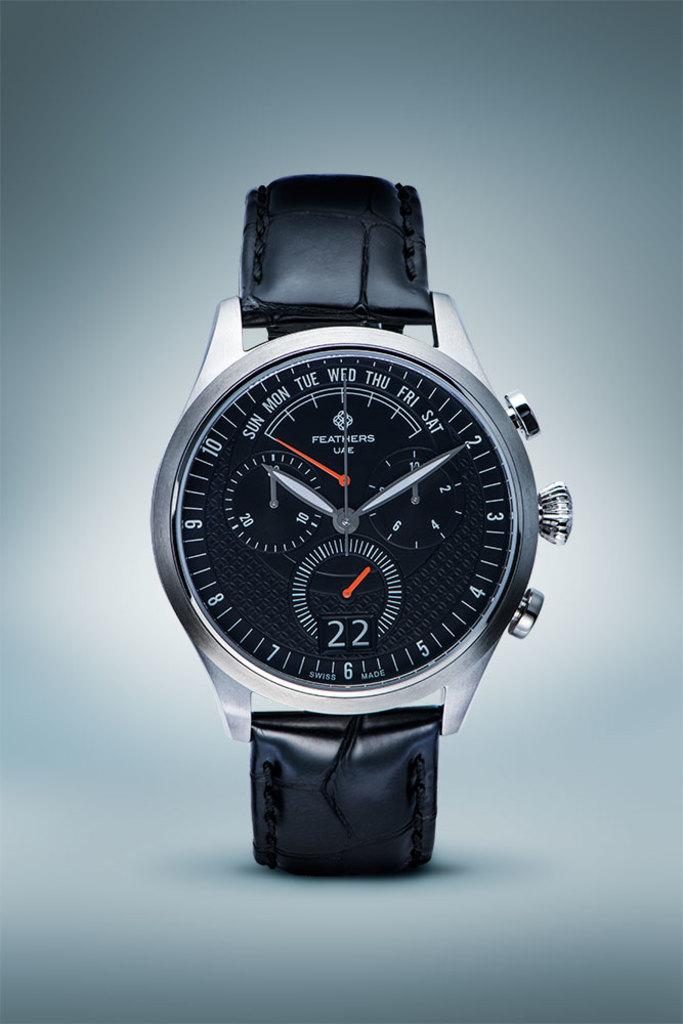What number does the big hand point to on the black watch?
Offer a terse response. 2. What big number is shown at the bottom?
Offer a very short reply. 22. 